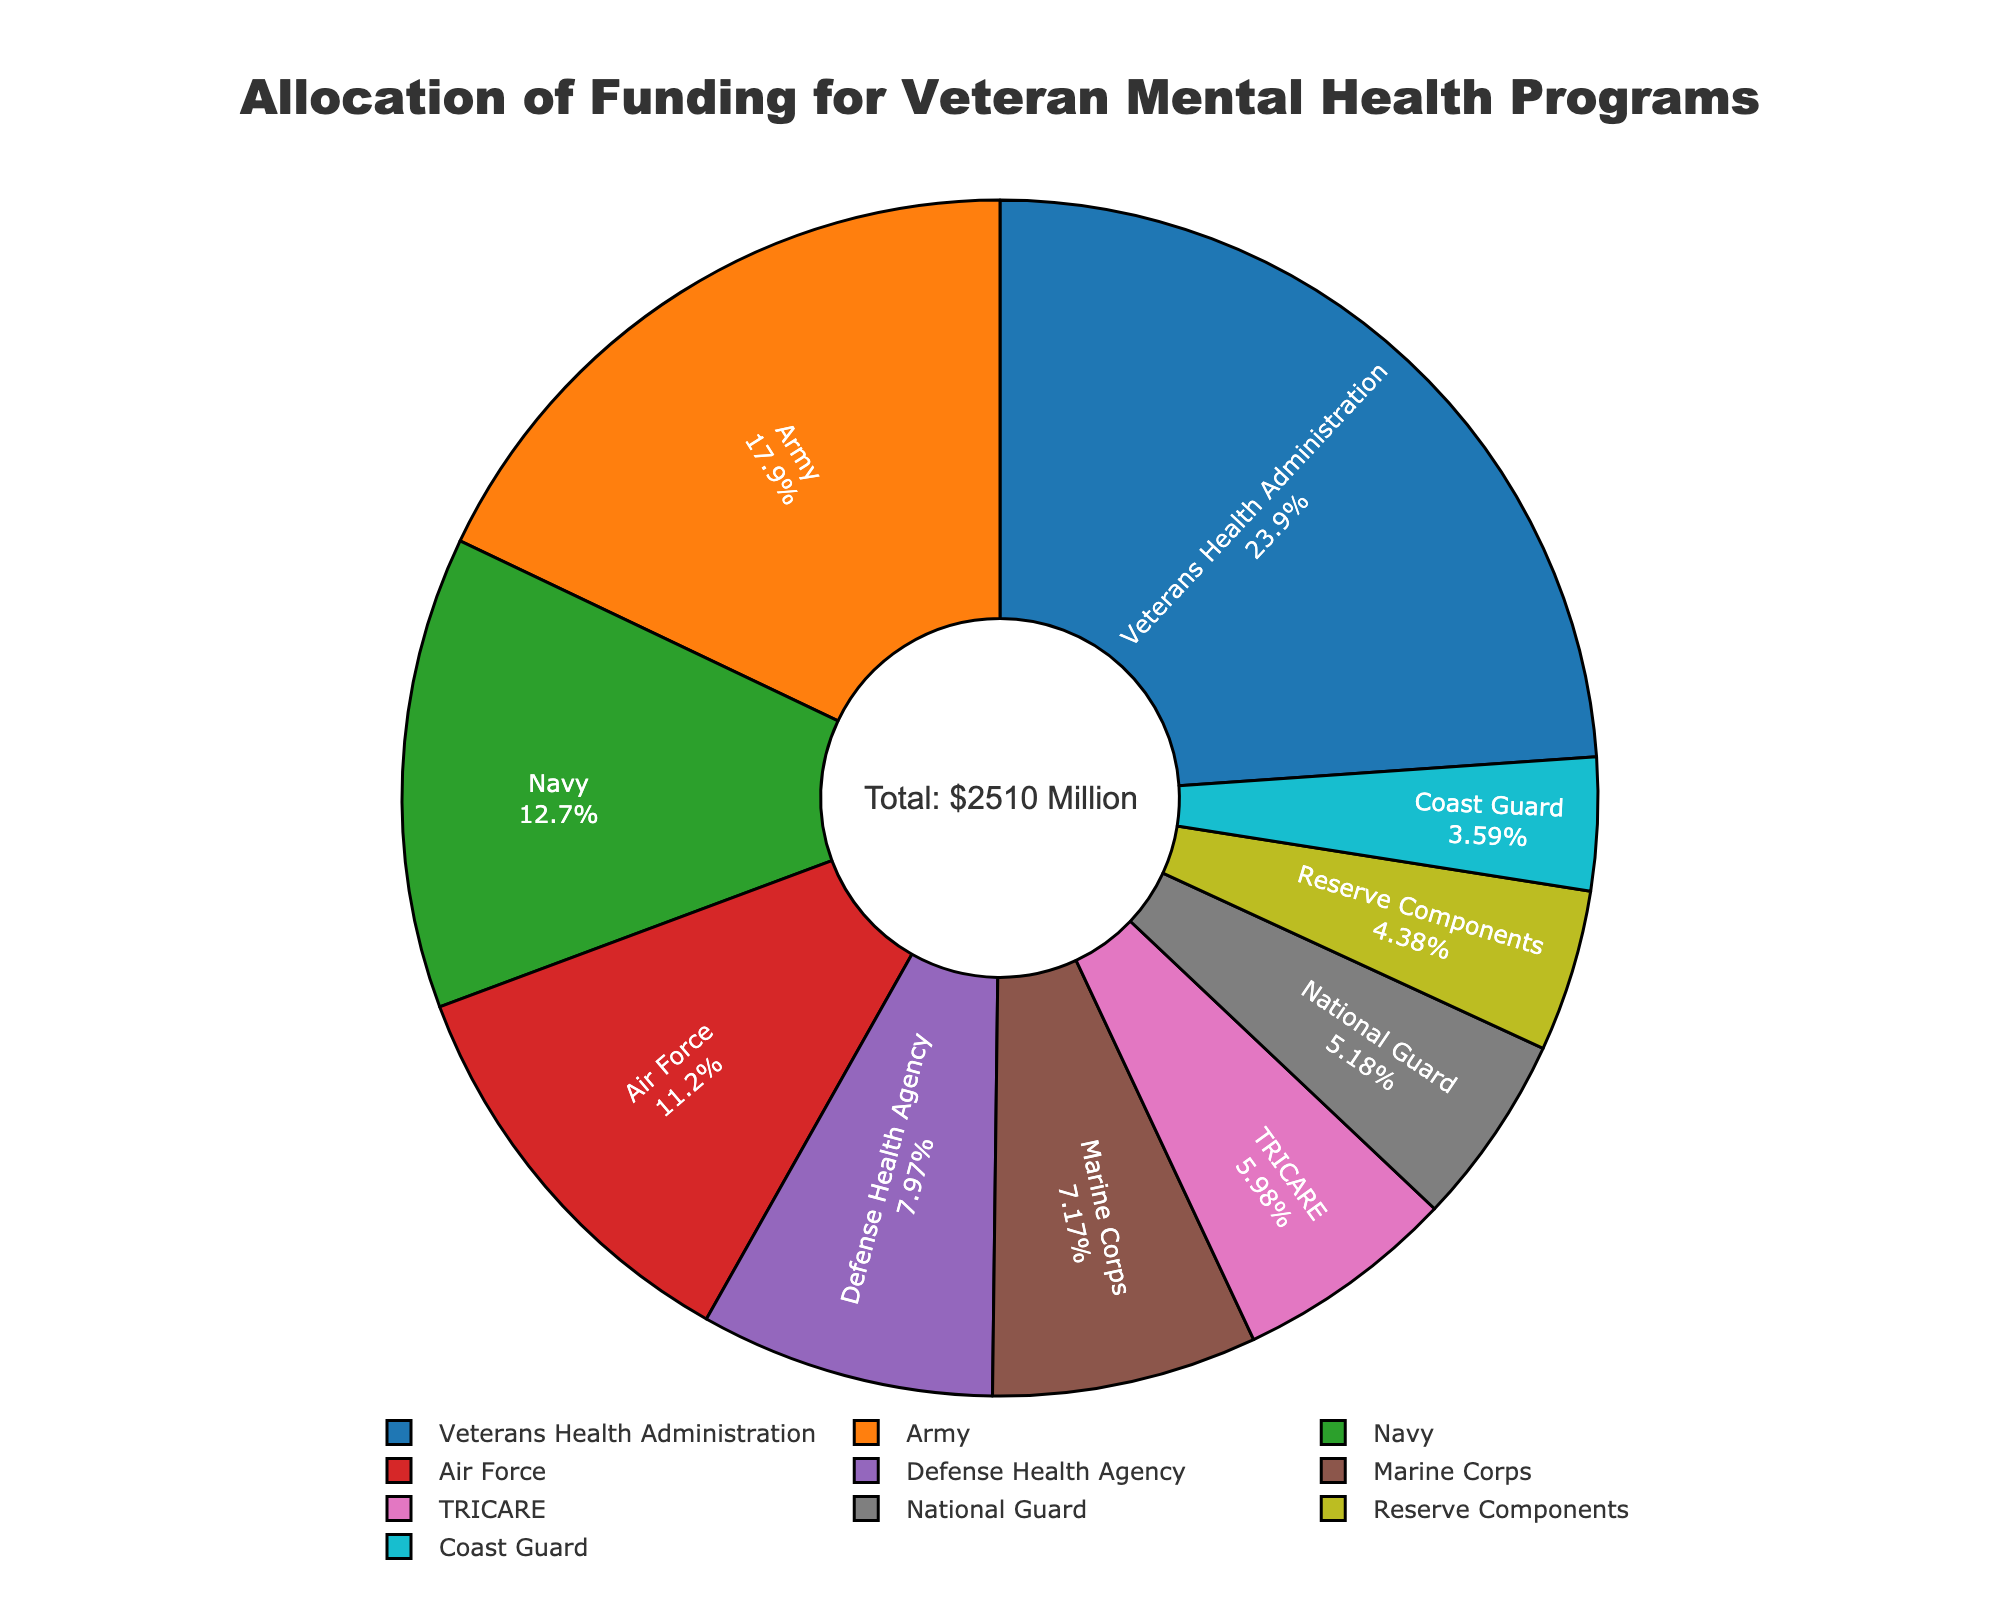what is the total funding allocated? The total funding can be found in the annotation text in the center of the pie chart showing "Total: $2510 Million"
Answer: $2510 Million Which service branch received the highest funding? The largest slice in the pie chart represents the funding for the Veterans Health Administration, which is highlighted as the branch with the highest funding in the figure.
Answer: Veterans Health Administration How much more funding does the Army receive compared to the Marine Corps? The pie chart provides the funding amounts for each branch: Army ($450M) and Marine Corps ($180M). The difference is calculated as $450M - $180M.
Answer: $270M What percentage of the total funding is allocated to TRICARE? The pie chart segments include the percentage allocations. Locate the TRICARE slice, and the percentage marked is approximately 6%.
Answer: 6% Are any two branches allocated equal funding? Carefully examining the slices and their labels, none of the branches have the same funding allocation as each slice represents a different segment size and label.
Answer: No What is the combined funding for the National Guard and Reserve Components? The pie chart provides the funding amounts for National Guard ($130M) and Reserve Components ($110M). The combined funding is calculated as $130M + $110M.
Answer: $240M What's the difference in funding between the Coast Guard and Defense Health Agency? The pie chart states the Coast Guard received $90M and the Defense Health Agency received $200M. The difference in funding is $200M - $90M.
Answer: $110M Which funding allocation is smaller, Marine Corps or Air Force? By comparing the slices in the pie chart, the Marine Corps is allocated $180M, and the Air Force is allocated $280M. Therefore, the Marine Corps has a smaller allocation.
Answer: Marine Corps What color represents the funding for the Navy? Observing the pie chart, each segment has a distinct color. The Navy's segment is identified with an orange color.
Answer: Orange What fraction of the total funding goes to the Veterans Health Administration? The Veterans Health Administration slice represents $600M out of the $2510M total. The fraction is simplified as 600/2510.
Answer: Approximately 3/13 